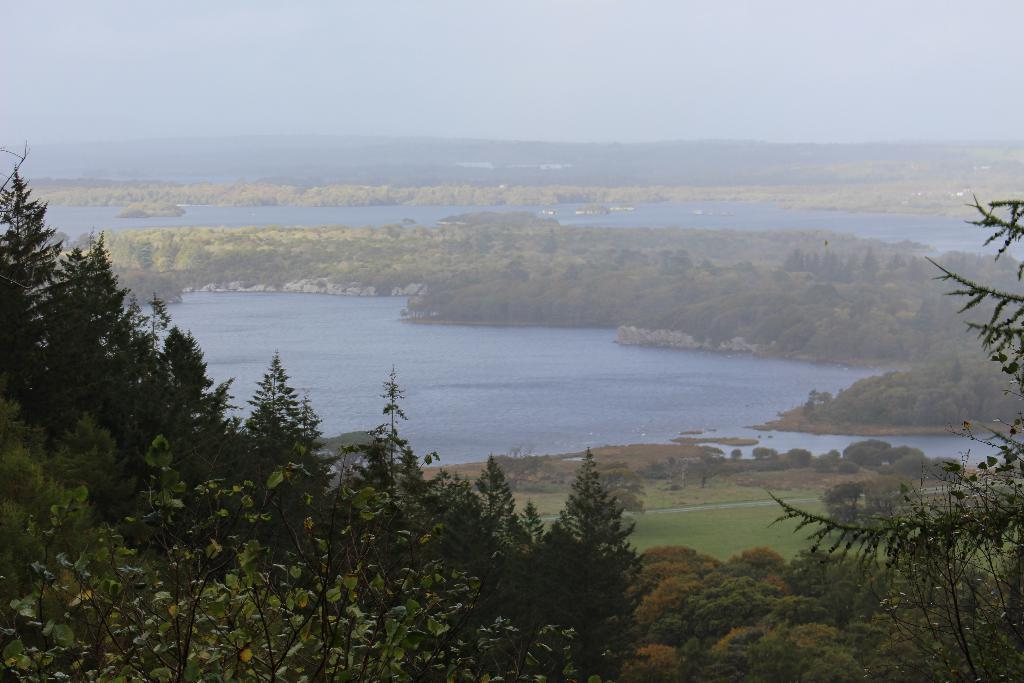What type of vegetation can be seen in the image? There are trees in the image. What else is visible besides the trees? There is water visible in the image. What can be seen in the background of the image? The sky is visible in the background of the image. What is the top of the tree doing in the image? There is no specific mention of the top of the tree in the image, so it is not possible to answer that question. 